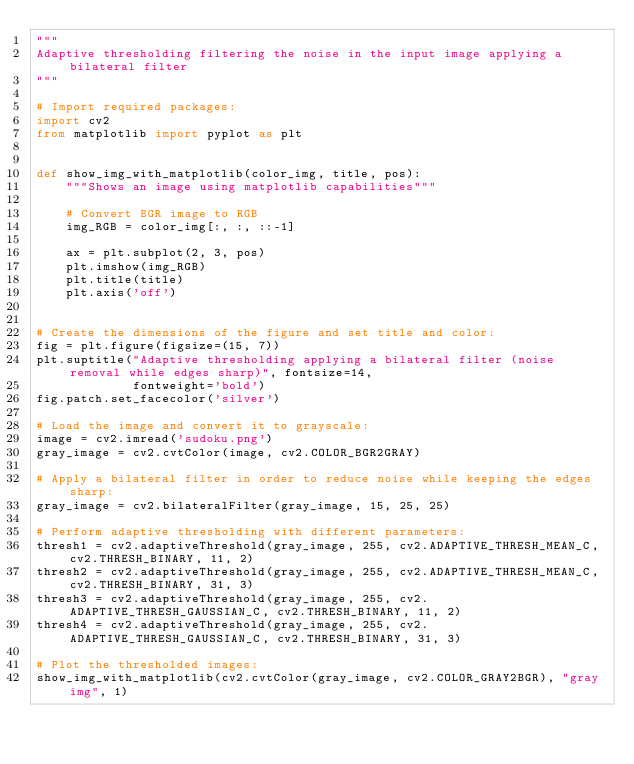<code> <loc_0><loc_0><loc_500><loc_500><_Python_>"""
Adaptive thresholding filtering the noise in the input image applying a bilateral filter
"""

# Import required packages:
import cv2
from matplotlib import pyplot as plt


def show_img_with_matplotlib(color_img, title, pos):
    """Shows an image using matplotlib capabilities"""

    # Convert BGR image to RGB
    img_RGB = color_img[:, :, ::-1]

    ax = plt.subplot(2, 3, pos)
    plt.imshow(img_RGB)
    plt.title(title)
    plt.axis('off')


# Create the dimensions of the figure and set title and color:
fig = plt.figure(figsize=(15, 7))
plt.suptitle("Adaptive thresholding applying a bilateral filter (noise removal while edges sharp)", fontsize=14,
             fontweight='bold')
fig.patch.set_facecolor('silver')

# Load the image and convert it to grayscale:
image = cv2.imread('sudoku.png')
gray_image = cv2.cvtColor(image, cv2.COLOR_BGR2GRAY)

# Apply a bilateral filter in order to reduce noise while keeping the edges sharp:
gray_image = cv2.bilateralFilter(gray_image, 15, 25, 25)

# Perform adaptive thresholding with different parameters:
thresh1 = cv2.adaptiveThreshold(gray_image, 255, cv2.ADAPTIVE_THRESH_MEAN_C, cv2.THRESH_BINARY, 11, 2)
thresh2 = cv2.adaptiveThreshold(gray_image, 255, cv2.ADAPTIVE_THRESH_MEAN_C, cv2.THRESH_BINARY, 31, 3)
thresh3 = cv2.adaptiveThreshold(gray_image, 255, cv2.ADAPTIVE_THRESH_GAUSSIAN_C, cv2.THRESH_BINARY, 11, 2)
thresh4 = cv2.adaptiveThreshold(gray_image, 255, cv2.ADAPTIVE_THRESH_GAUSSIAN_C, cv2.THRESH_BINARY, 31, 3)

# Plot the thresholded images:
show_img_with_matplotlib(cv2.cvtColor(gray_image, cv2.COLOR_GRAY2BGR), "gray img", 1)</code> 